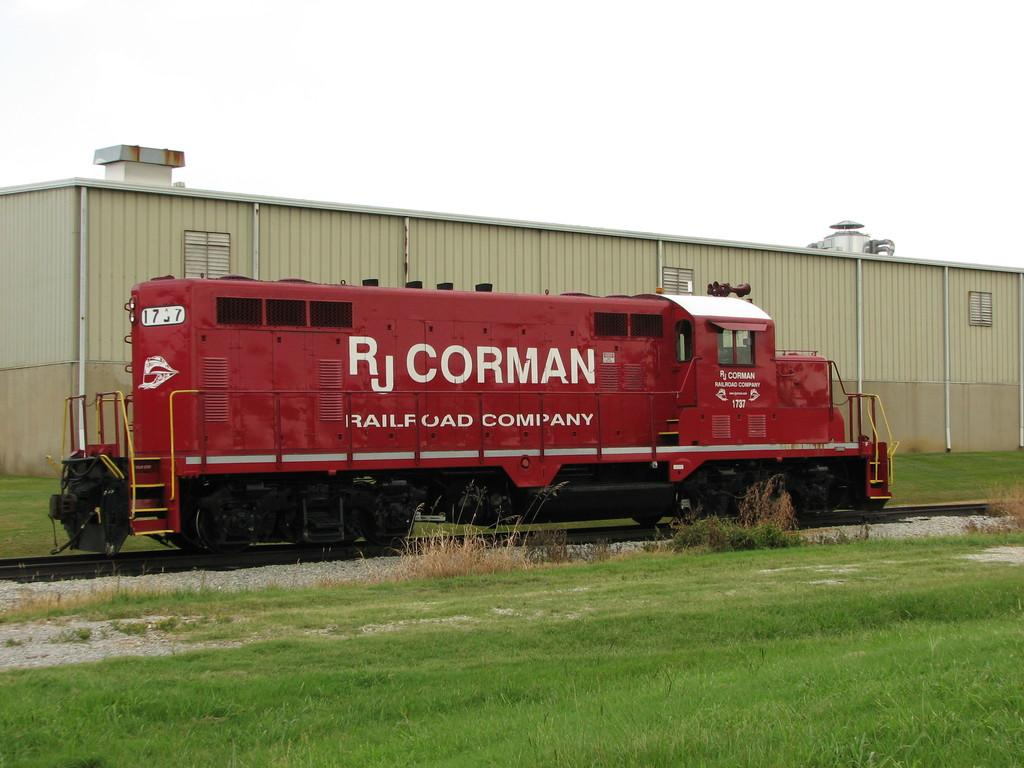<image>
Give a short and clear explanation of the subsequent image. A large red vehicle has the logo for RJ Corman on the side. 